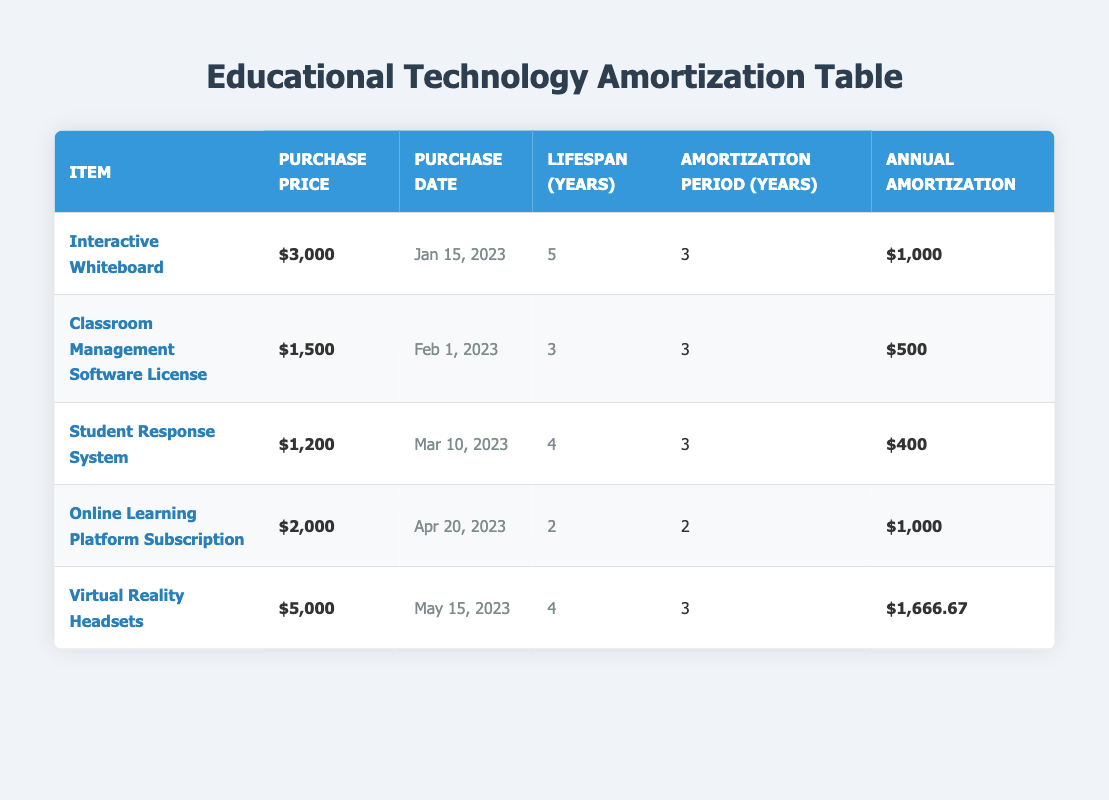What is the purchase price of the "Interactive Whiteboard"? The table lists the purchase price of the Interactive Whiteboard as $3000.
Answer: $3000 How many items have an amortization period of 3 years? By examining the table, we can see that the "Interactive Whiteboard," "Classroom Management Software License," "Student Response System," and "Virtual Reality Headsets," have an amortization period of 3 years. That's a total of 4 items.
Answer: 4 What is the total purchase price of all items listed in the table? The total purchase price is computed by adding up all individual purchase prices: 3000 + 1500 + 1200 + 2000 + 5000 = 13700.
Answer: 13700 Is the "Online Learning Platform Subscription" amortized over 3 years? The table shows that the Online Learning Platform Subscription has an amortization period of 2 years, not 3. Therefore, the statement is false.
Answer: No What is the average annual amortization amount of the items with a purchase price greater than $2000? First, we identify the items with a purchase price greater than $2000: "Interactive Whiteboard" ($1000 annual amortization) and "Virtual Reality Headsets" ($1666.67 annual amortization). Then sum them up: 1000 + 1666.67 = 2666.67. The average is 2666.67 divided by 2, which equals 1333.33.
Answer: 1333.33 Which item has the longest lifespan, and what is its lifespan? The "Interactive Whiteboard" has the longest lifespan of 5 years, as seen in the table alongside other items.
Answer: Interactive Whiteboard, 5 years What is the sum of the annual amortization amounts for items with a lifespan of 3 years? The items with a lifespan of 3 years are the "Classroom Management Software License" ($500) and the "Online Learning Platform Subscription" ($1000). Adding these amounts together: 500 + 1000 = 1500.
Answer: 1500 Is the annual amortization of the "Virtual Reality Headsets" more than $1500? The table shows the annual amortization for the Virtual Reality Headsets as $1666.67, which is greater than $1500. Thus, the statement is true.
Answer: Yes 